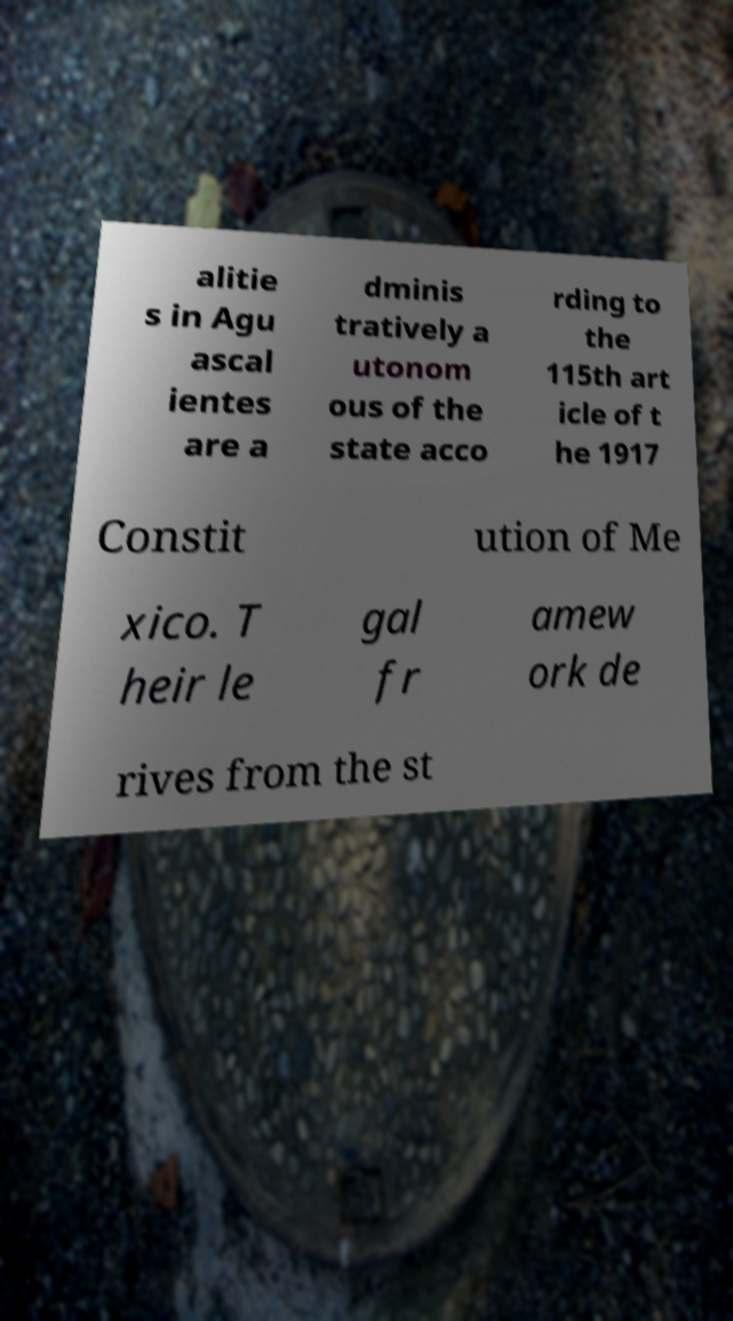I need the written content from this picture converted into text. Can you do that? alitie s in Agu ascal ientes are a dminis tratively a utonom ous of the state acco rding to the 115th art icle of t he 1917 Constit ution of Me xico. T heir le gal fr amew ork de rives from the st 